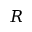Convert formula to latex. <formula><loc_0><loc_0><loc_500><loc_500>R</formula> 